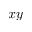<formula> <loc_0><loc_0><loc_500><loc_500>x y</formula> 